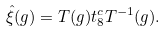Convert formula to latex. <formula><loc_0><loc_0><loc_500><loc_500>\hat { \xi } ( g ) = T ( g ) t _ { 8 } ^ { c } T ^ { - 1 } ( g ) .</formula> 